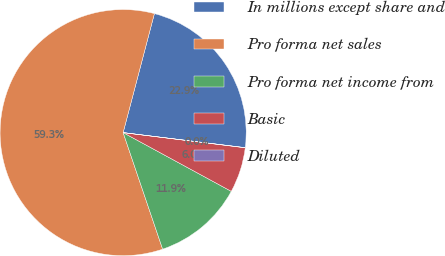Convert chart. <chart><loc_0><loc_0><loc_500><loc_500><pie_chart><fcel>In millions except share and<fcel>Pro forma net sales<fcel>Pro forma net income from<fcel>Basic<fcel>Diluted<nl><fcel>22.86%<fcel>59.29%<fcel>11.88%<fcel>5.95%<fcel>0.02%<nl></chart> 